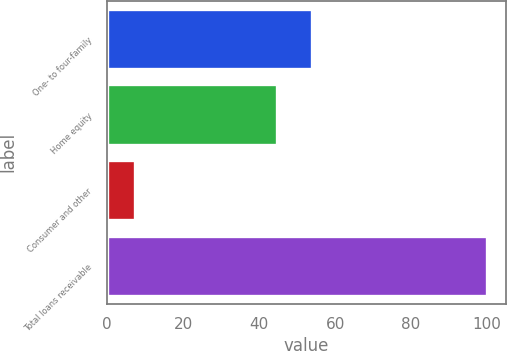Convert chart. <chart><loc_0><loc_0><loc_500><loc_500><bar_chart><fcel>One- to four-family<fcel>Home equity<fcel>Consumer and other<fcel>Total loans receivable<nl><fcel>53.88<fcel>44.6<fcel>7.2<fcel>100<nl></chart> 